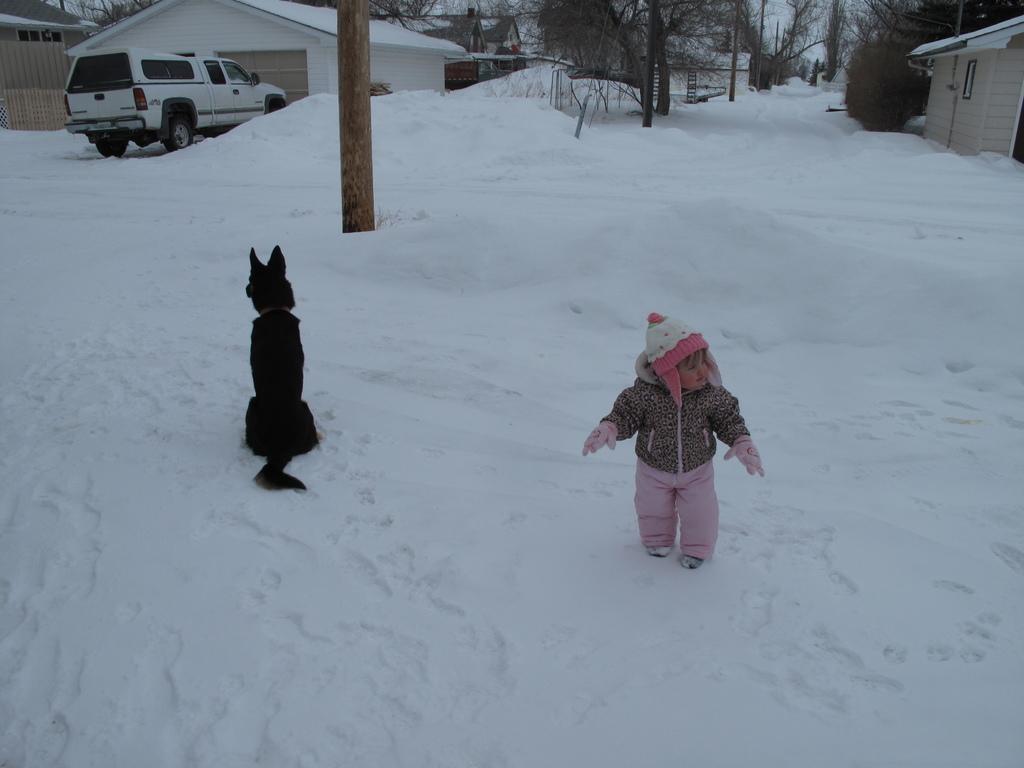Can you describe this image briefly? There is one dog and a kid present on a snowy ground as we can see in the middle of this image. There is a vehicle, trees and houses are present at the top of this image. 